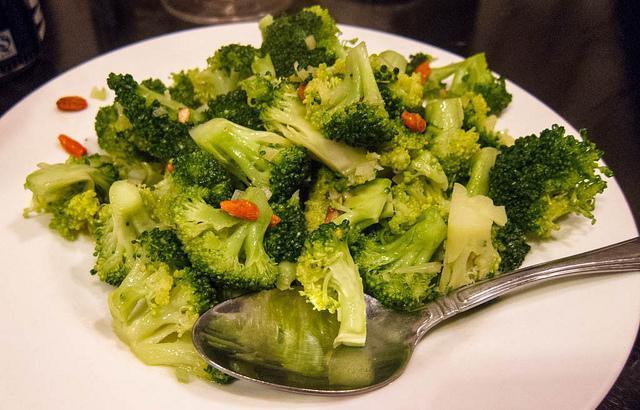How many men are in the pic?
Give a very brief answer. 0. 